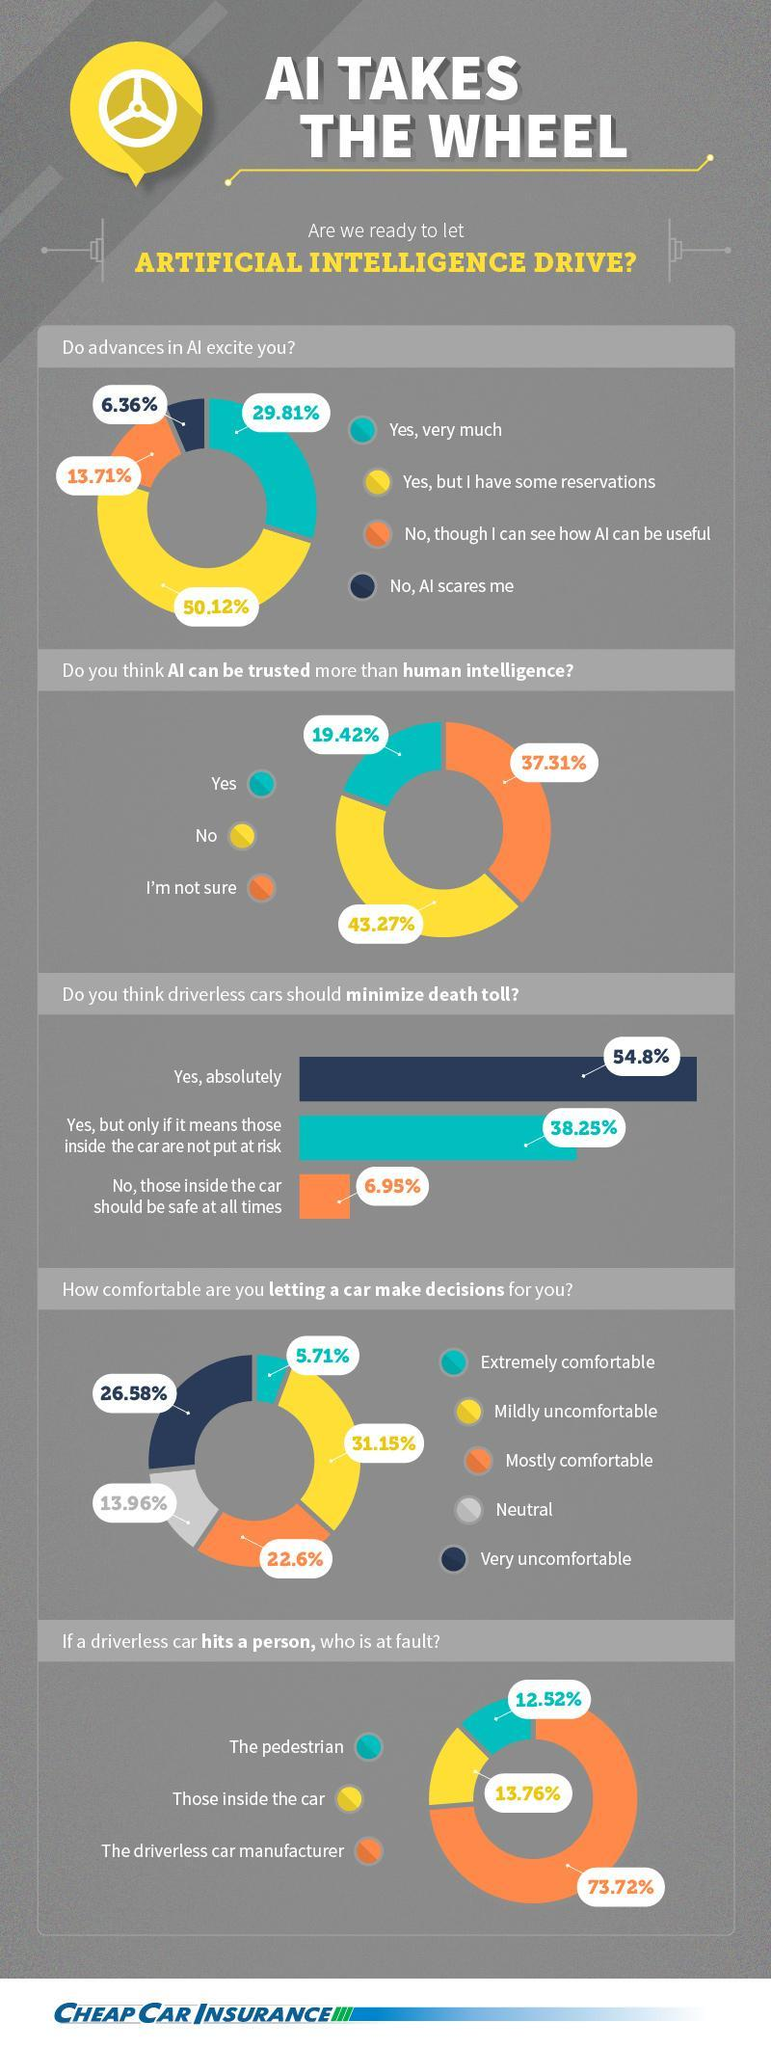What percent of people think that AI can be trusted more than human intelligence?
Answer the question with a short phrase. 19.42% What do 26.58% people think about letting a car make decisions for them? Very uncomfortable What percent of people are very much excited about advances in AI? 29.81% What do the majority of people say when asked if AI can be trusted more than human intelligence? No What is the opinion of 50.12% of people regarding advances in AI? Yes, but I have some reservations What percent of people are mostly comfortable in letting a car make decisions for them? 22.6% What is the difference between people who think that driverless cars should or should not minimize death tolls? 47.85% What do most people think about who is at fault if a driverless car hits a person? The driverless car manufacturer What percent of people say that pedestrians are at fault if a driverless car hits them? 12.52% What percent of people say that AI can be useful and AI scares them? 20.07% 